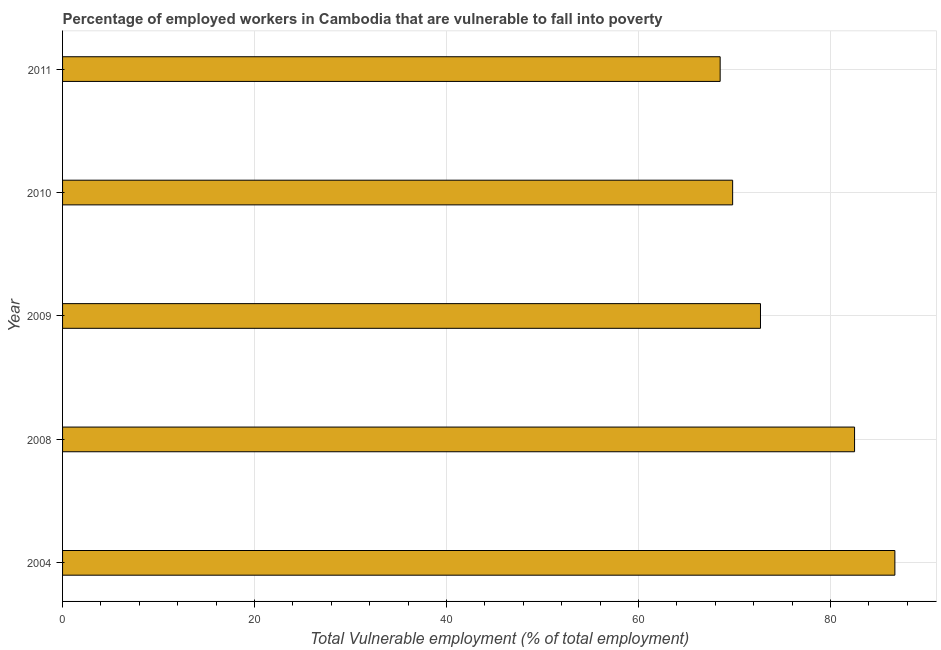Does the graph contain any zero values?
Provide a short and direct response. No. Does the graph contain grids?
Offer a very short reply. Yes. What is the title of the graph?
Keep it short and to the point. Percentage of employed workers in Cambodia that are vulnerable to fall into poverty. What is the label or title of the X-axis?
Your answer should be very brief. Total Vulnerable employment (% of total employment). What is the label or title of the Y-axis?
Your response must be concise. Year. What is the total vulnerable employment in 2004?
Provide a short and direct response. 86.7. Across all years, what is the maximum total vulnerable employment?
Your answer should be compact. 86.7. Across all years, what is the minimum total vulnerable employment?
Keep it short and to the point. 68.5. In which year was the total vulnerable employment maximum?
Offer a terse response. 2004. In which year was the total vulnerable employment minimum?
Offer a very short reply. 2011. What is the sum of the total vulnerable employment?
Your answer should be compact. 380.2. What is the difference between the total vulnerable employment in 2009 and 2011?
Ensure brevity in your answer.  4.2. What is the average total vulnerable employment per year?
Provide a short and direct response. 76.04. What is the median total vulnerable employment?
Provide a short and direct response. 72.7. Do a majority of the years between 2009 and 2011 (inclusive) have total vulnerable employment greater than 4 %?
Offer a very short reply. Yes. Is the total vulnerable employment in 2004 less than that in 2011?
Give a very brief answer. No. What is the difference between the highest and the second highest total vulnerable employment?
Give a very brief answer. 4.2. How many bars are there?
Make the answer very short. 5. Are all the bars in the graph horizontal?
Offer a very short reply. Yes. How many years are there in the graph?
Make the answer very short. 5. Are the values on the major ticks of X-axis written in scientific E-notation?
Ensure brevity in your answer.  No. What is the Total Vulnerable employment (% of total employment) in 2004?
Ensure brevity in your answer.  86.7. What is the Total Vulnerable employment (% of total employment) in 2008?
Provide a succinct answer. 82.5. What is the Total Vulnerable employment (% of total employment) of 2009?
Offer a terse response. 72.7. What is the Total Vulnerable employment (% of total employment) of 2010?
Keep it short and to the point. 69.8. What is the Total Vulnerable employment (% of total employment) of 2011?
Offer a very short reply. 68.5. What is the difference between the Total Vulnerable employment (% of total employment) in 2004 and 2008?
Offer a very short reply. 4.2. What is the difference between the Total Vulnerable employment (% of total employment) in 2004 and 2009?
Provide a succinct answer. 14. What is the difference between the Total Vulnerable employment (% of total employment) in 2004 and 2010?
Offer a terse response. 16.9. What is the difference between the Total Vulnerable employment (% of total employment) in 2008 and 2009?
Your response must be concise. 9.8. What is the difference between the Total Vulnerable employment (% of total employment) in 2008 and 2011?
Your answer should be compact. 14. What is the difference between the Total Vulnerable employment (% of total employment) in 2009 and 2010?
Offer a terse response. 2.9. What is the difference between the Total Vulnerable employment (% of total employment) in 2010 and 2011?
Provide a short and direct response. 1.3. What is the ratio of the Total Vulnerable employment (% of total employment) in 2004 to that in 2008?
Your answer should be very brief. 1.05. What is the ratio of the Total Vulnerable employment (% of total employment) in 2004 to that in 2009?
Offer a terse response. 1.19. What is the ratio of the Total Vulnerable employment (% of total employment) in 2004 to that in 2010?
Provide a succinct answer. 1.24. What is the ratio of the Total Vulnerable employment (% of total employment) in 2004 to that in 2011?
Make the answer very short. 1.27. What is the ratio of the Total Vulnerable employment (% of total employment) in 2008 to that in 2009?
Ensure brevity in your answer.  1.14. What is the ratio of the Total Vulnerable employment (% of total employment) in 2008 to that in 2010?
Ensure brevity in your answer.  1.18. What is the ratio of the Total Vulnerable employment (% of total employment) in 2008 to that in 2011?
Make the answer very short. 1.2. What is the ratio of the Total Vulnerable employment (% of total employment) in 2009 to that in 2010?
Offer a very short reply. 1.04. What is the ratio of the Total Vulnerable employment (% of total employment) in 2009 to that in 2011?
Ensure brevity in your answer.  1.06. 